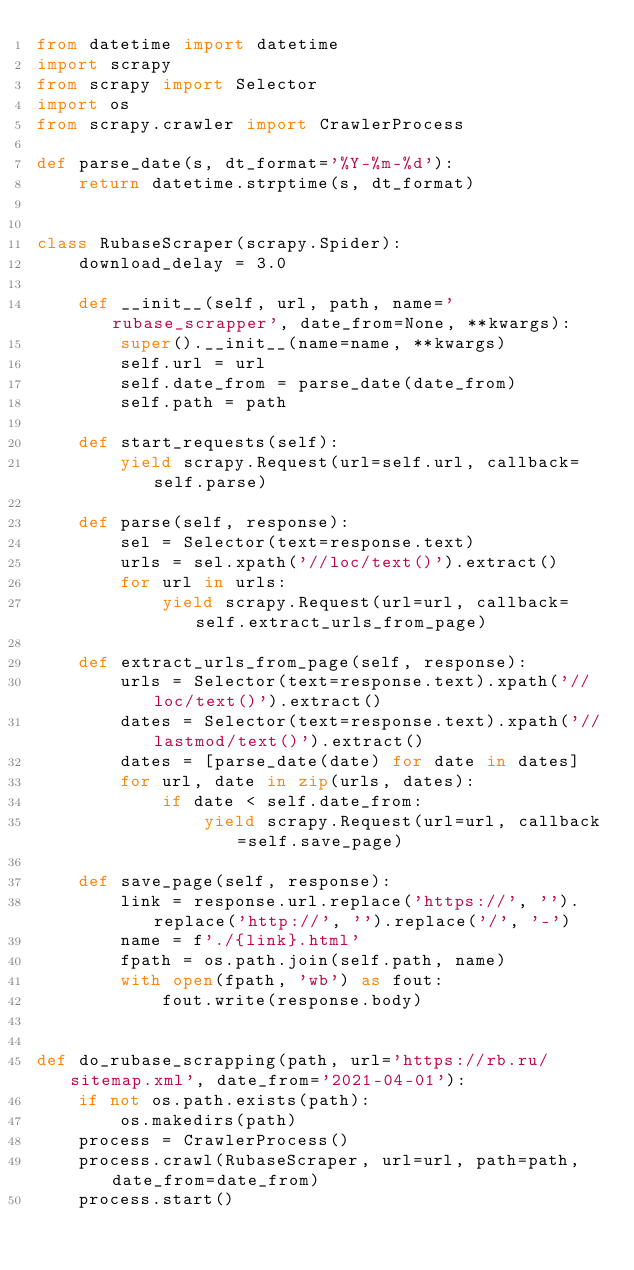<code> <loc_0><loc_0><loc_500><loc_500><_Python_>from datetime import datetime
import scrapy
from scrapy import Selector
import os
from scrapy.crawler import CrawlerProcess

def parse_date(s, dt_format='%Y-%m-%d'):
    return datetime.strptime(s, dt_format)


class RubaseScraper(scrapy.Spider):
    download_delay = 3.0

    def __init__(self, url, path, name='rubase_scrapper', date_from=None, **kwargs):
        super().__init__(name=name, **kwargs)
        self.url = url
        self.date_from = parse_date(date_from)
        self.path = path

    def start_requests(self):
        yield scrapy.Request(url=self.url, callback=self.parse)

    def parse(self, response):
        sel = Selector(text=response.text)
        urls = sel.xpath('//loc/text()').extract()
        for url in urls:
            yield scrapy.Request(url=url, callback=self.extract_urls_from_page)

    def extract_urls_from_page(self, response):
        urls = Selector(text=response.text).xpath('//loc/text()').extract()
        dates = Selector(text=response.text).xpath('//lastmod/text()').extract()
        dates = [parse_date(date) for date in dates]
        for url, date in zip(urls, dates):
            if date < self.date_from:
                yield scrapy.Request(url=url, callback=self.save_page)

    def save_page(self, response):
        link = response.url.replace('https://', '').replace('http://', '').replace('/', '-')
        name = f'./{link}.html'
        fpath = os.path.join(self.path, name)
        with open(fpath, 'wb') as fout:
            fout.write(response.body)


def do_rubase_scrapping(path, url='https://rb.ru/sitemap.xml', date_from='2021-04-01'):
    if not os.path.exists(path):
        os.makedirs(path)
    process = CrawlerProcess()
    process.crawl(RubaseScraper, url=url, path=path, date_from=date_from)
    process.start()</code> 